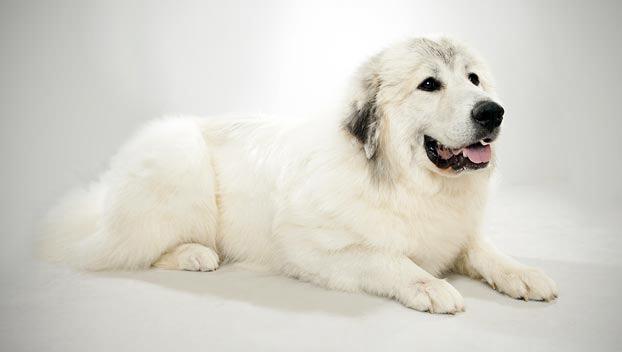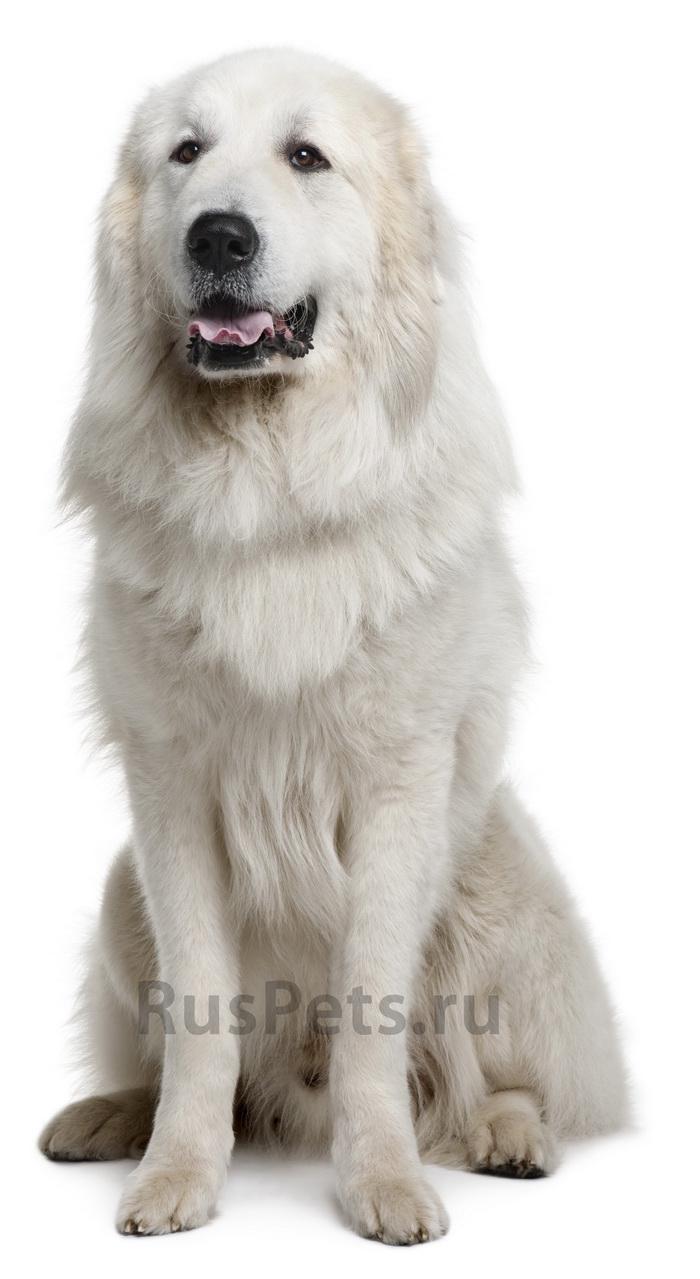The first image is the image on the left, the second image is the image on the right. Examine the images to the left and right. Is the description "There is a dog standing in snow in the images." accurate? Answer yes or no. No. 